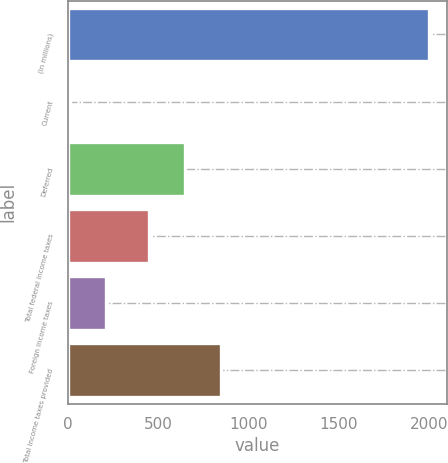Convert chart to OTSL. <chart><loc_0><loc_0><loc_500><loc_500><bar_chart><fcel>(In millions)<fcel>Current<fcel>Deferred<fcel>Total federal income taxes<fcel>Foreign income taxes<fcel>Total income taxes provided<nl><fcel>2003<fcel>14<fcel>651.9<fcel>453<fcel>212.9<fcel>850.8<nl></chart> 